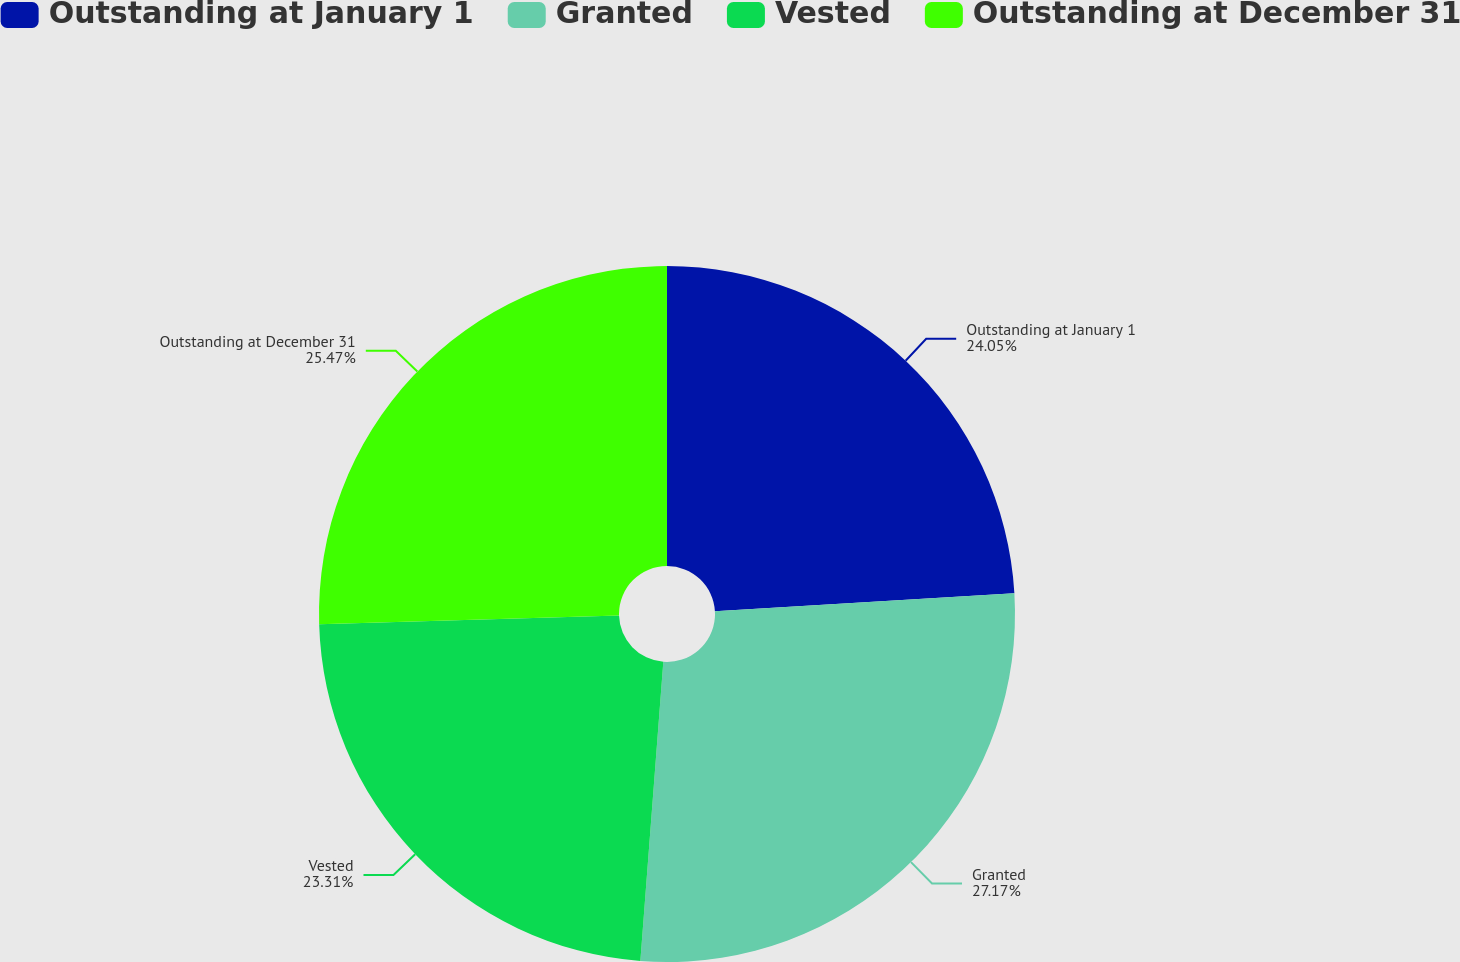Convert chart to OTSL. <chart><loc_0><loc_0><loc_500><loc_500><pie_chart><fcel>Outstanding at January 1<fcel>Granted<fcel>Vested<fcel>Outstanding at December 31<nl><fcel>24.05%<fcel>27.17%<fcel>23.31%<fcel>25.47%<nl></chart> 